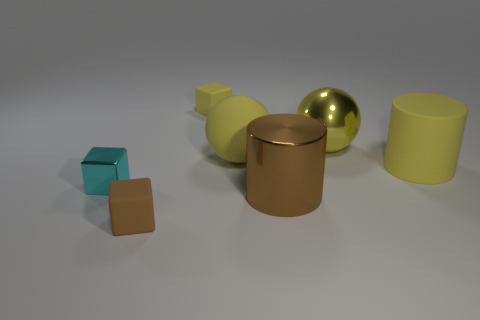Subtract all yellow cylinders. How many cylinders are left? 1 Subtract all small yellow blocks. How many blocks are left? 2 Subtract 0 blue spheres. How many objects are left? 7 Subtract all cylinders. How many objects are left? 5 Subtract 1 cylinders. How many cylinders are left? 1 Subtract all brown cylinders. Subtract all purple blocks. How many cylinders are left? 1 Subtract all brown balls. How many yellow cylinders are left? 1 Subtract all large cyan objects. Subtract all brown metallic cylinders. How many objects are left? 6 Add 1 big yellow spheres. How many big yellow spheres are left? 3 Add 5 rubber balls. How many rubber balls exist? 6 